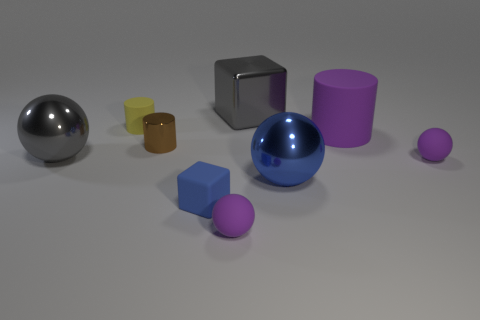There is a matte cylinder that is the same size as the gray cube; what is its color?
Provide a succinct answer. Purple. What number of metallic objects are either brown things or gray things?
Your response must be concise. 3. What number of objects are behind the brown metallic object and to the right of the tiny yellow object?
Give a very brief answer. 2. How many other objects are the same size as the yellow rubber object?
Provide a succinct answer. 4. There is a rubber ball that is in front of the blue block; does it have the same size as the metallic ball on the right side of the big gray cube?
Your response must be concise. No. What number of things are either gray balls or purple rubber objects in front of the large gray sphere?
Your response must be concise. 3. There is a cube that is behind the gray metal ball; what is its size?
Give a very brief answer. Large. Is the number of purple rubber things that are in front of the purple rubber cylinder less than the number of things that are right of the brown object?
Offer a very short reply. Yes. The small object that is both right of the small blue block and behind the large blue ball is made of what material?
Your response must be concise. Rubber. What is the shape of the object that is behind the tiny yellow rubber cylinder behind the purple rubber cylinder?
Keep it short and to the point. Cube. 